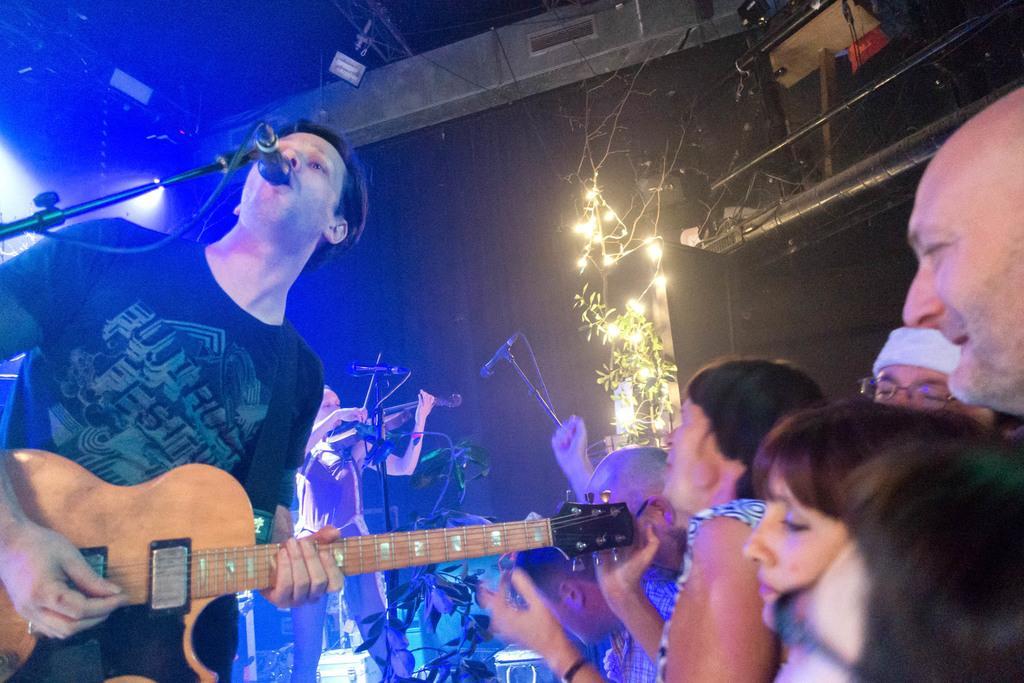In one or two sentences, can you explain what this image depicts? In this picture a black shirt guy is playing a guitar and singing with a mic placed in front of him. We also observed spectators cheering him in the right side of the image. In the background we observe lights attached to the trees and equipment fitted to the roof. 